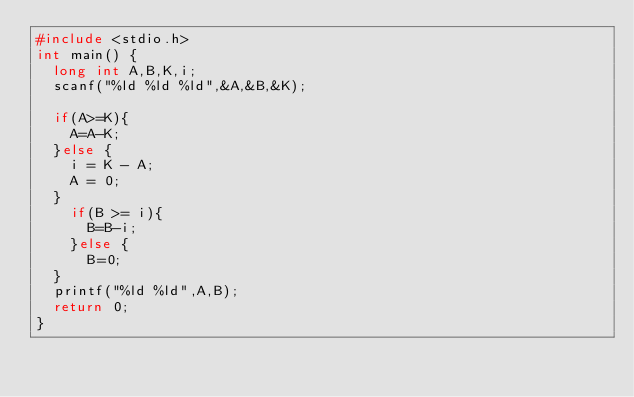Convert code to text. <code><loc_0><loc_0><loc_500><loc_500><_C_>#include <stdio.h>
int main() {
  long int A,B,K,i;
  scanf("%ld %ld %ld",&A,&B,&K);

  if(A>=K){
    A=A-K;
  }else {
    i = K - A;
    A = 0;
  }
    if(B >= i){
      B=B-i;
    }else {
      B=0;
  }
  printf("%ld %ld",A,B);
  return 0;
}
</code> 